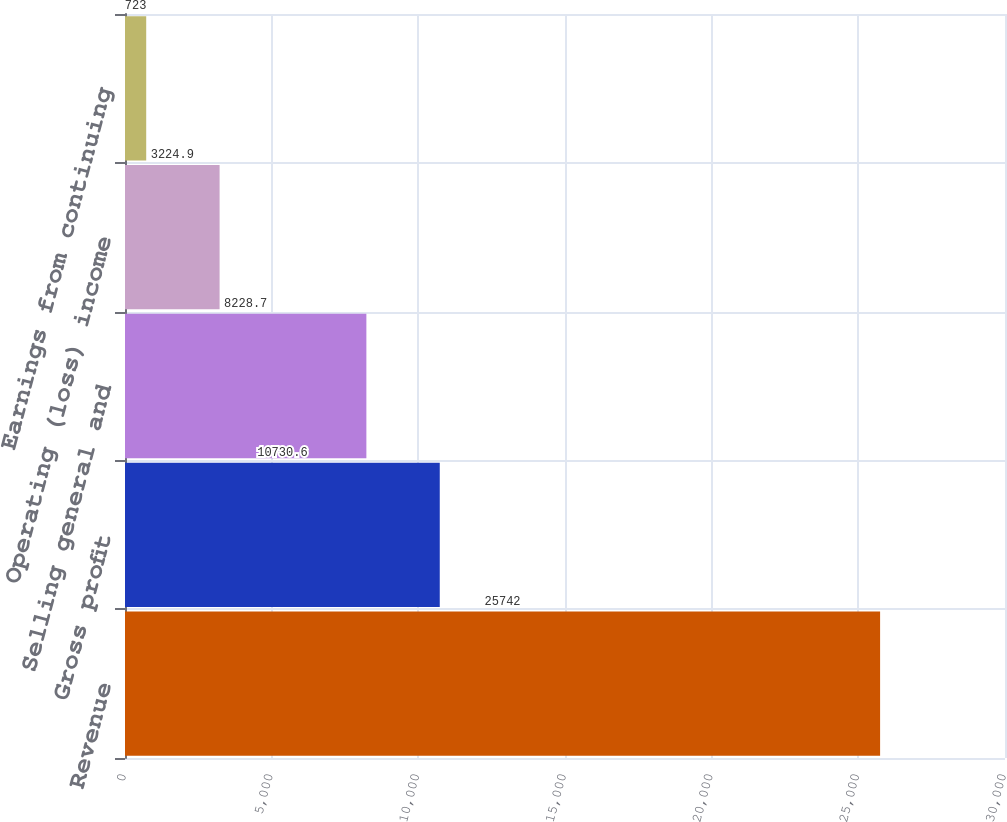<chart> <loc_0><loc_0><loc_500><loc_500><bar_chart><fcel>Revenue<fcel>Gross profit<fcel>Selling general and<fcel>Operating (loss) income<fcel>Earnings from continuing<nl><fcel>25742<fcel>10730.6<fcel>8228.7<fcel>3224.9<fcel>723<nl></chart> 